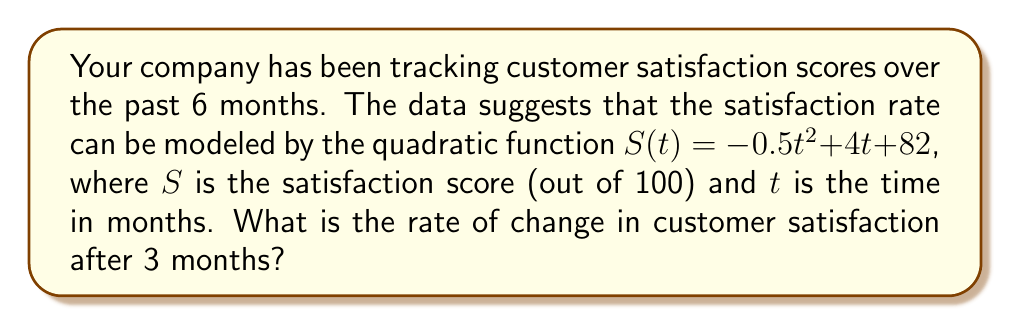Give your solution to this math problem. To solve this problem, we need to find the rate of change of the satisfaction function $S(t)$ at $t = 3$ months. The rate of change is given by the derivative of the function.

Step 1: Find the derivative of $S(t)$.
The function is $S(t) = -0.5t^2 + 4t + 82$
The derivative is $S'(t) = -t + 4$

Step 2: Calculate the rate of change at $t = 3$ months.
Substitute $t = 3$ into the derivative function:
$S'(3) = -3 + 4 = 1$

The positive value indicates that customer satisfaction is still increasing at this point, but the rate of increase is slowing down due to the negative coefficient of $t^2$ in the original function.
Answer: The rate of change in customer satisfaction after 3 months is 1 point per month. 